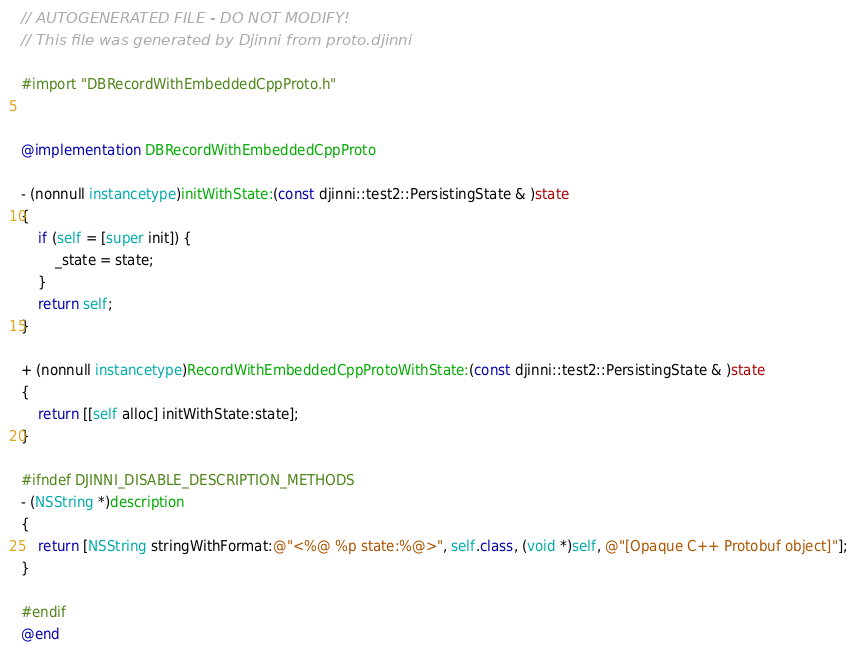<code> <loc_0><loc_0><loc_500><loc_500><_ObjectiveC_>// AUTOGENERATED FILE - DO NOT MODIFY!
// This file was generated by Djinni from proto.djinni

#import "DBRecordWithEmbeddedCppProto.h"


@implementation DBRecordWithEmbeddedCppProto

- (nonnull instancetype)initWithState:(const djinni::test2::PersistingState & )state
{
    if (self = [super init]) {
        _state = state;
    }
    return self;
}

+ (nonnull instancetype)RecordWithEmbeddedCppProtoWithState:(const djinni::test2::PersistingState & )state
{
    return [[self alloc] initWithState:state];
}

#ifndef DJINNI_DISABLE_DESCRIPTION_METHODS
- (NSString *)description
{
    return [NSString stringWithFormat:@"<%@ %p state:%@>", self.class, (void *)self, @"[Opaque C++ Protobuf object]"];
}

#endif
@end
</code> 